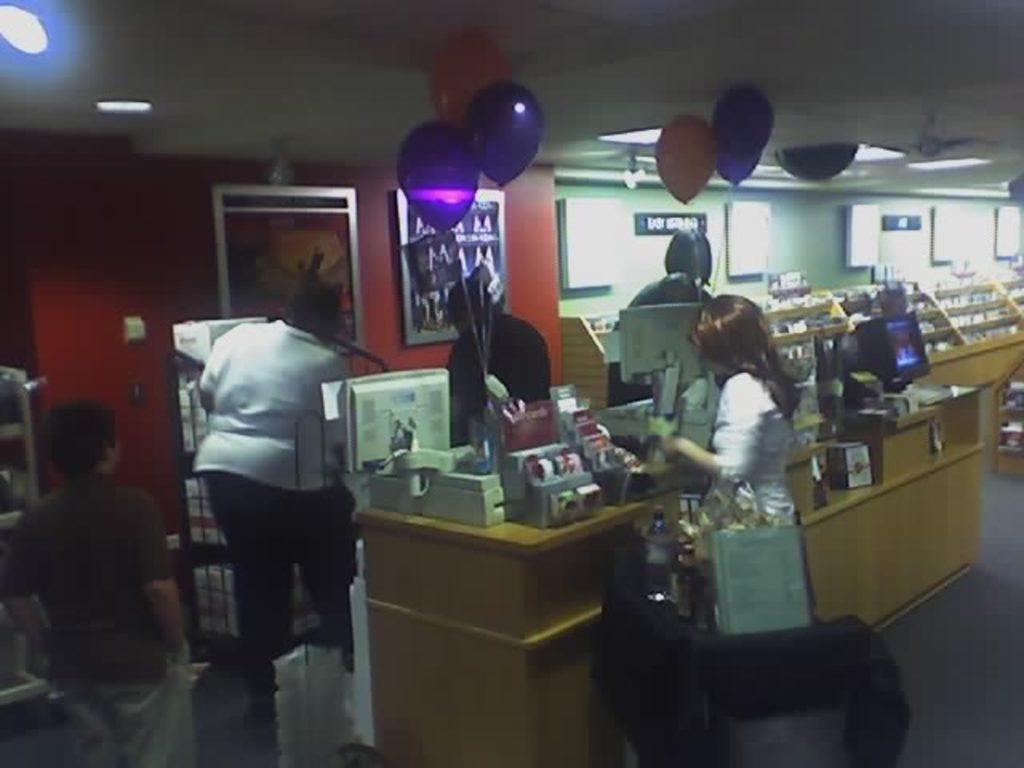How would you summarize this image in a sentence or two? there is a store in which there are tables. on the table there are objects. people are standing. there are balloons. at the left there is a red wall on which there are photo frames. behind that there is a green wall. on the top there are fan and lights. 